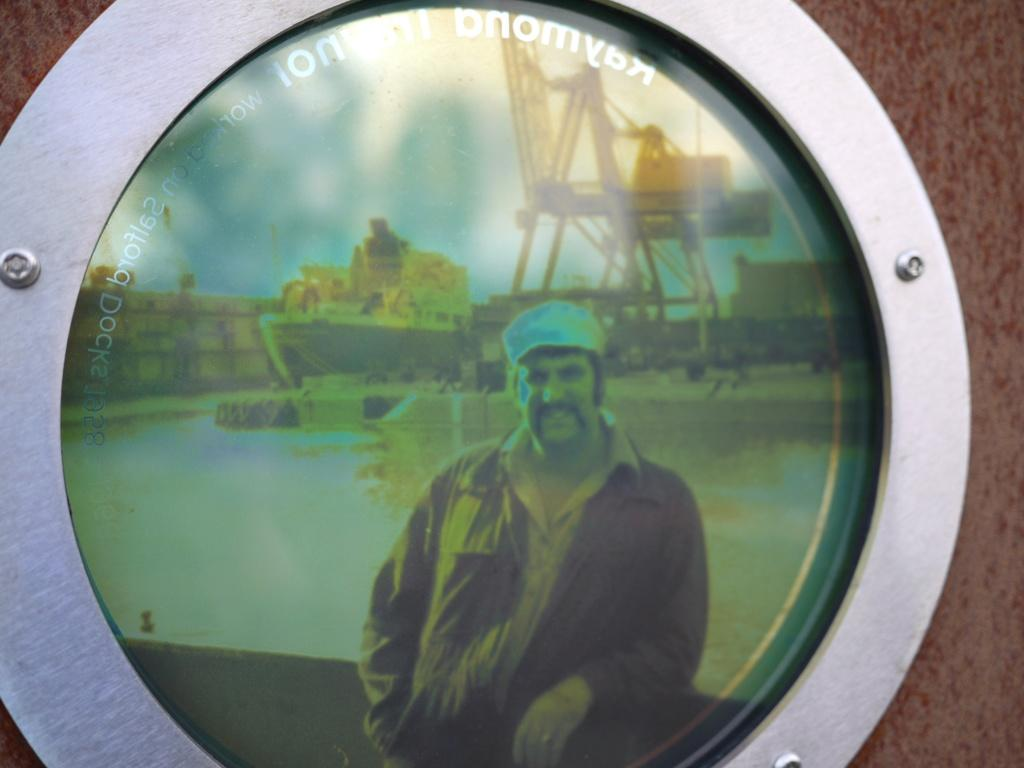What is hanging on the wall in the image? There is a photo frame on the wall. What is inside the photo frame? The photo frame contains a picture. What elements are included in the picture? The picture includes a person, a ship, a shipyard, a building, and the sky. What type of rod can be seen in the image? There is no rod present in the image. 